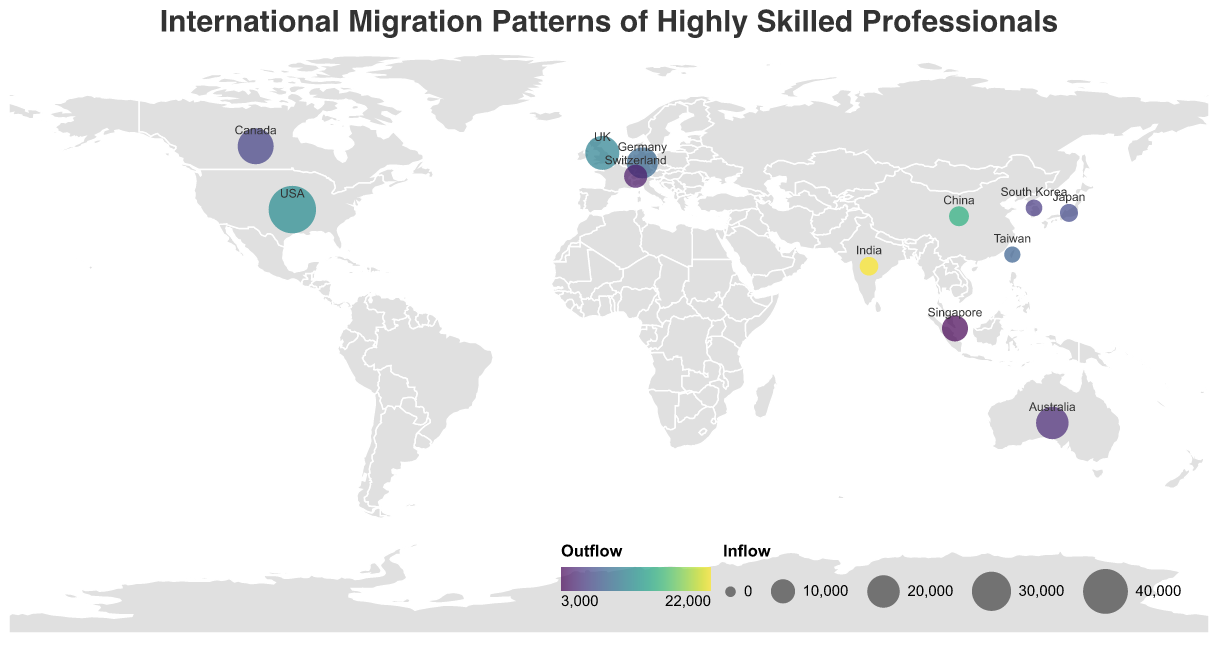What's the country with the highest outflow of highly skilled professionals? By observing the color intensity of the circles, which represent the outflow, we can see that India has the highest outflow at 22000.
Answer: India Which country has the highest inflow of highly skilled professionals? The size of the circles indicates the inflow. The largest circle corresponds to the USA, with an inflow of 45000.
Answer: USA What is the top destination for professionals from Taiwan? The tooltip information for Taiwan shows that the top destination country is the USA.
Answer: USA How does the inflow of highly skilled professionals into Germany compare to that into Canada? By looking at the size of the circles for Germany and Canada, Germany has an inflow of 18000, while Canada has 25000, making Germany's inflow smaller.
Answer: Canada's inflow is larger What is the combined outflow of highly skilled professionals from the USA and China? From the data, the outflow for the USA is 12000 and for China is 15000. Summing these values gives 12000 + 15000 = 27000.
Answer: 27000 Which countries have an inflow greater than 20000? By examining the sizes of the circles, the countries with inflow greater than 20000 are the USA, the UK, Canada, and Australia.
Answer: USA, UK, Canada, Australia What is the top origin country for highly skilled professionals in Australia? Referring to the tooltip for Australia, the top origin country is China.
Answer: China How many countries have an outflow greater than 10000? By looking at the color intensity of the circles, four countries have an outflow greater than 10000: USA, China, UK, and India.
Answer: 4 What is the net migration (inflow - outflow) for Singapore? For Singapore, the inflow is 12000 and the outflow is 3000. The net migration is 12000 - 3000 = 9000.
Answer: 9000 Which country has the smallest outflow among the listed countries? By observing the color intensity of the circles, which represents the outflow, Singapore has the smallest outflow at 3000.
Answer: Singapore 